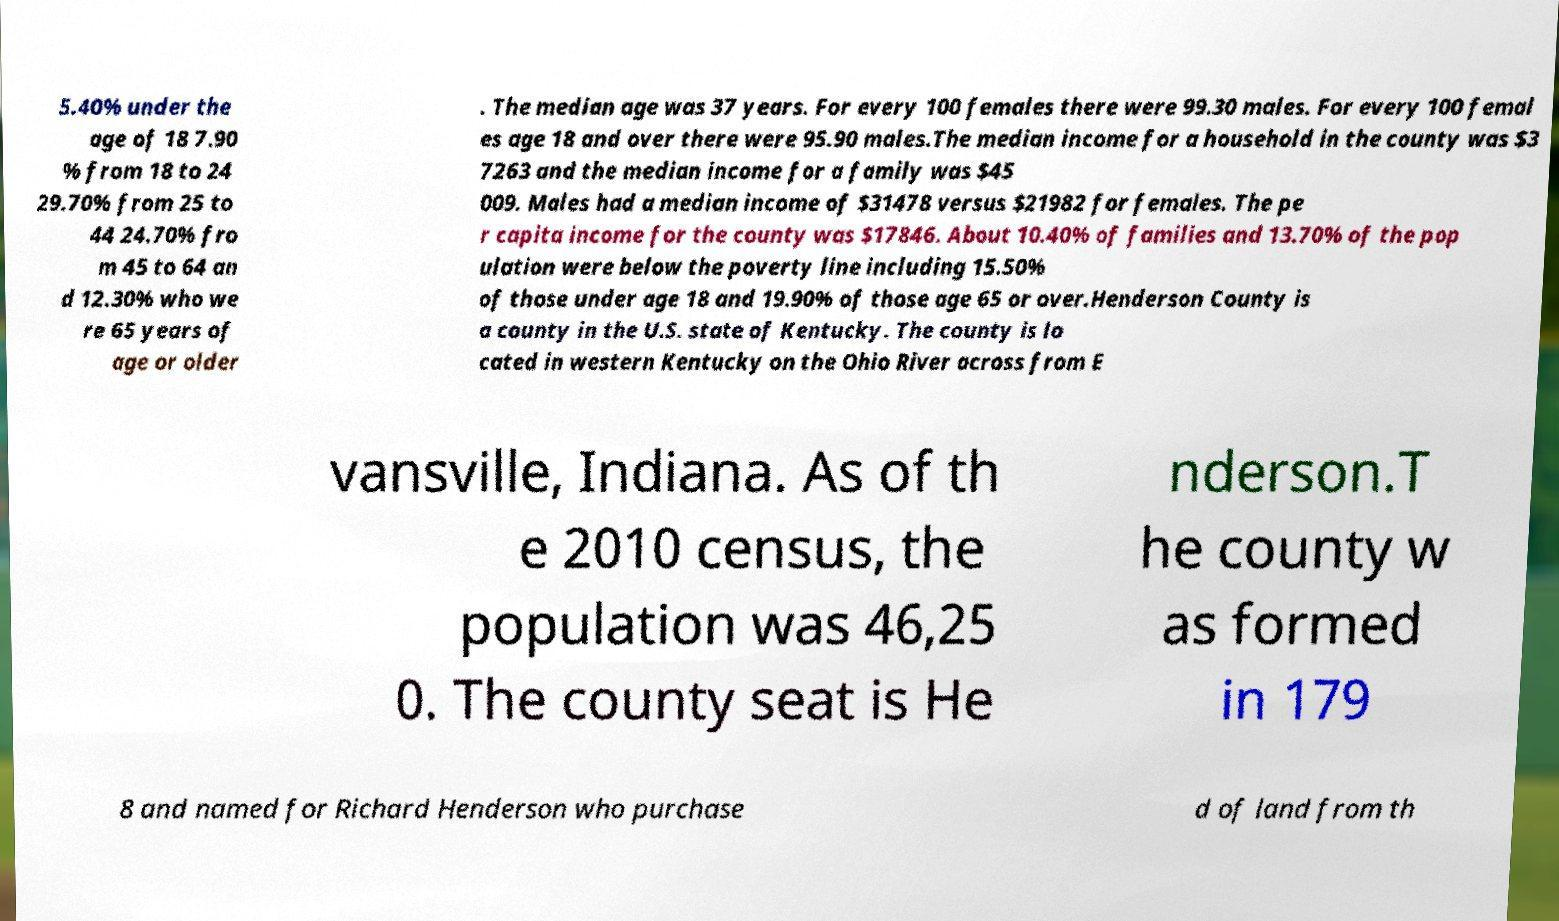Could you assist in decoding the text presented in this image and type it out clearly? 5.40% under the age of 18 7.90 % from 18 to 24 29.70% from 25 to 44 24.70% fro m 45 to 64 an d 12.30% who we re 65 years of age or older . The median age was 37 years. For every 100 females there were 99.30 males. For every 100 femal es age 18 and over there were 95.90 males.The median income for a household in the county was $3 7263 and the median income for a family was $45 009. Males had a median income of $31478 versus $21982 for females. The pe r capita income for the county was $17846. About 10.40% of families and 13.70% of the pop ulation were below the poverty line including 15.50% of those under age 18 and 19.90% of those age 65 or over.Henderson County is a county in the U.S. state of Kentucky. The county is lo cated in western Kentucky on the Ohio River across from E vansville, Indiana. As of th e 2010 census, the population was 46,25 0. The county seat is He nderson.T he county w as formed in 179 8 and named for Richard Henderson who purchase d of land from th 